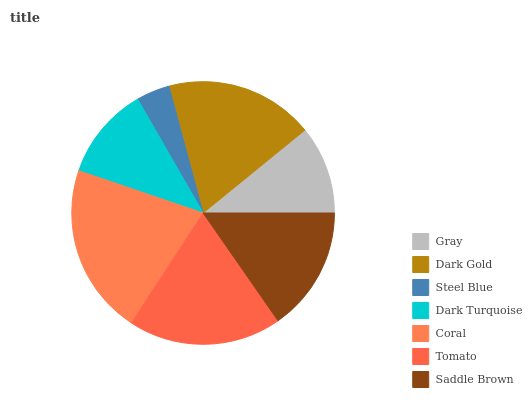Is Steel Blue the minimum?
Answer yes or no. Yes. Is Coral the maximum?
Answer yes or no. Yes. Is Dark Gold the minimum?
Answer yes or no. No. Is Dark Gold the maximum?
Answer yes or no. No. Is Dark Gold greater than Gray?
Answer yes or no. Yes. Is Gray less than Dark Gold?
Answer yes or no. Yes. Is Gray greater than Dark Gold?
Answer yes or no. No. Is Dark Gold less than Gray?
Answer yes or no. No. Is Saddle Brown the high median?
Answer yes or no. Yes. Is Saddle Brown the low median?
Answer yes or no. Yes. Is Gray the high median?
Answer yes or no. No. Is Gray the low median?
Answer yes or no. No. 